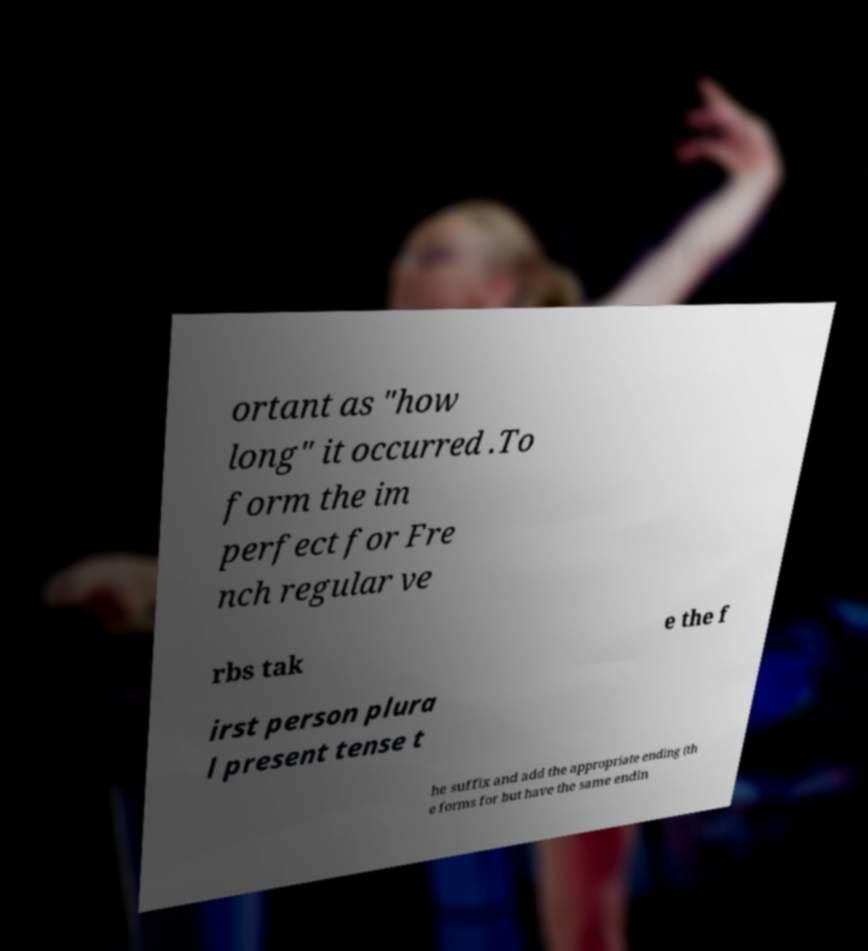Can you accurately transcribe the text from the provided image for me? ortant as "how long" it occurred .To form the im perfect for Fre nch regular ve rbs tak e the f irst person plura l present tense t he suffix and add the appropriate ending (th e forms for but have the same endin 